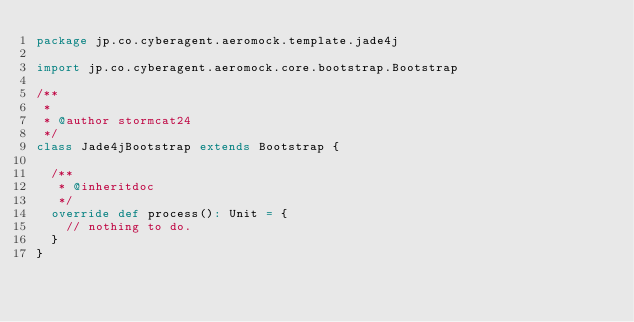Convert code to text. <code><loc_0><loc_0><loc_500><loc_500><_Scala_>package jp.co.cyberagent.aeromock.template.jade4j

import jp.co.cyberagent.aeromock.core.bootstrap.Bootstrap

/**
 *
 * @author stormcat24
 */
class Jade4jBootstrap extends Bootstrap {

  /**
   * @inheritdoc
   */
  override def process(): Unit = {
    // nothing to do.
  }
}
</code> 